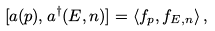<formula> <loc_0><loc_0><loc_500><loc_500>[ a ( { p } ) , a ^ { \dagger } ( E , { n } ) ] = \langle f _ { p } , f _ { E , { n } } \rangle \, ,</formula> 